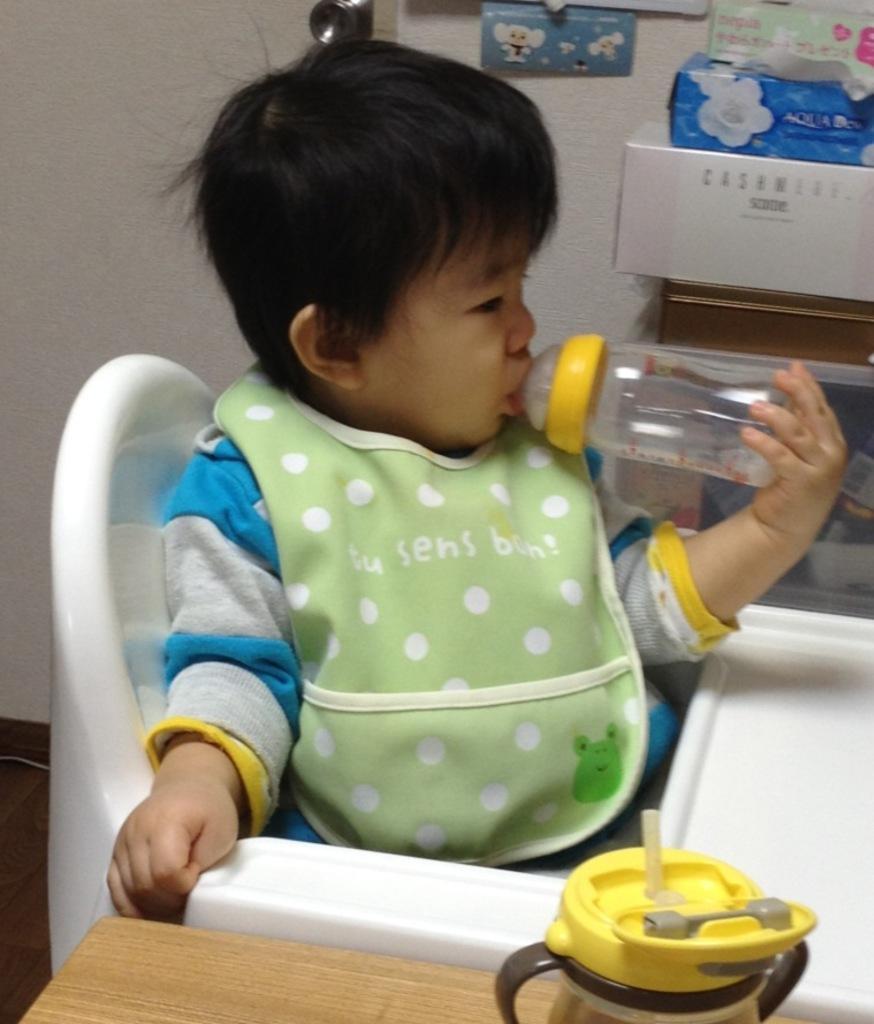Could you give a brief overview of what you see in this image? In this picture we can see a kid is sitting on a baby dining chair and holding a bottle, there is another bottle at the bottom, in the background we can see a wall and boxes. 